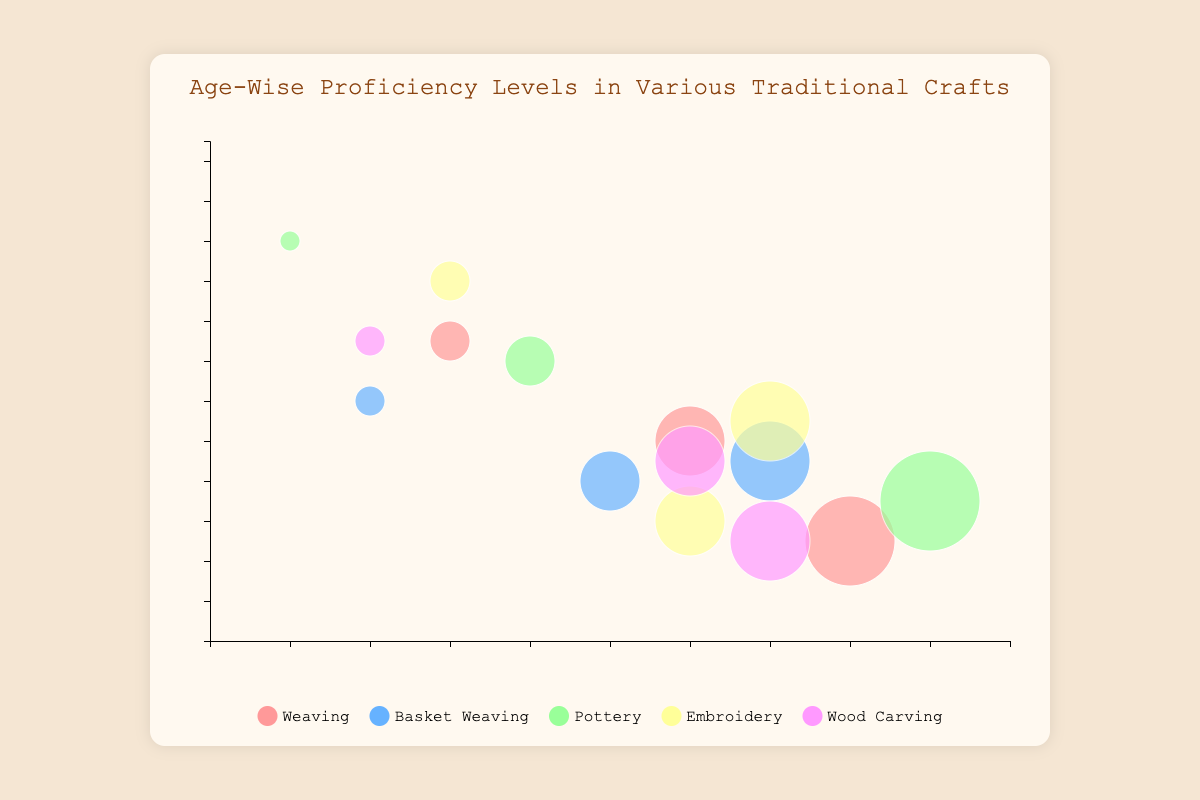What is the title of the bubble chart? The title is displayed at the top of the chart in large text, which reads "Age-Wise Proficiency Levels in Various Traditional Crafts."
Answer: Age-Wise Proficiency Levels in Various Traditional Crafts Which craft has the highest proficiency level for the 31-40 age group? Look for the bubbles labeled "31-40" and observe the horizontal position (Proficiency Level) and the color representing different crafts. The rightmost bubble for this age group indicates the highest level.
Answer: Pottery How many participants are there in the weaving craft for the 21-30 age group? Identify the bubble for "Weaving" colored accordingly that sits around the horizontal position for proficiency level 6. Then, check its vertical position for the number of participants.
Answer: 10 Which craft has the most participants in the 10-20 age group? Locate all the bubbles labeled "10-20" and compare their vertical positions (Number of Participants). The highest positioned bubble represents the craft with the most participants.
Answer: Pottery Compare the proficiency levels of the 21-30 age group in Basket Weaving and Wood Carving. Which one is higher? Find the bubbles labeled "21-30" for both Basket Weaving and Wood Carving, then compare their horizontal positions (Proficiency Level).
Answer: Wood Carving What is the average number of participants for weaving across all age groups? Extract the number of participants for weaving at each proficiency level (15, 10, 5). Sum them up, then divide by the total number of data points: (15 + 10 + 5) / 3.
Answer: 10 Which age group has a proficiency level of 9 in pottery, and how many participants are there for this group? Find the bubble for "Pottery" with a proficiency level of 9. The age group label and the vertical placement of the bubble will provide the answer.
Answer: 31-40, 7 Identify the craft with the least overall proficiency level across all age groups. Analyze the horizontal placement (Proficiency Level) of bubbles representing each craft and find the lowest proficiency level. Pottery, with a proficiency level of 1 for the 10-20 age group, is the least.
Answer: Pottery How does the proficiency level of embroidery for the 10-20 age group compare to that of the 21-30 age group? Locate the bubbles for "Embroidery" for both age groups and compare their horizontal positions.
Answer: Lower In terms of proficiency levels, which craft shows the greatest improvement from the 10-20 age group to the 31-40 age group? Compare the increase in horizontal distance (Proficiency Level) between bubbles labeled "10-20" and "31-40" across each craft. Pottery shows an increased proficiency level from 1 to 9.
Answer: Pottery 